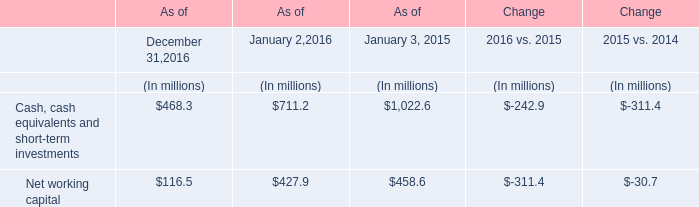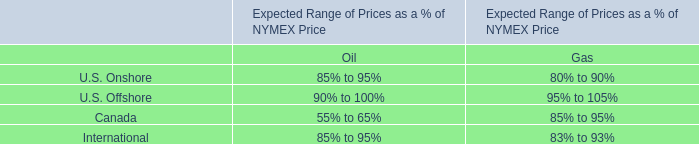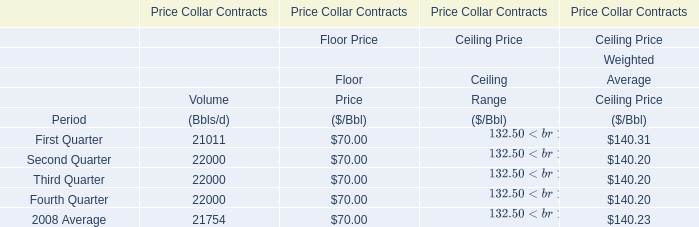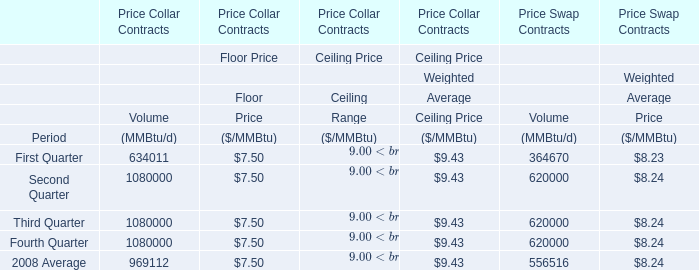What's the greatest value of Volume in First Quarter, 2008? 
Answer: 634011. 